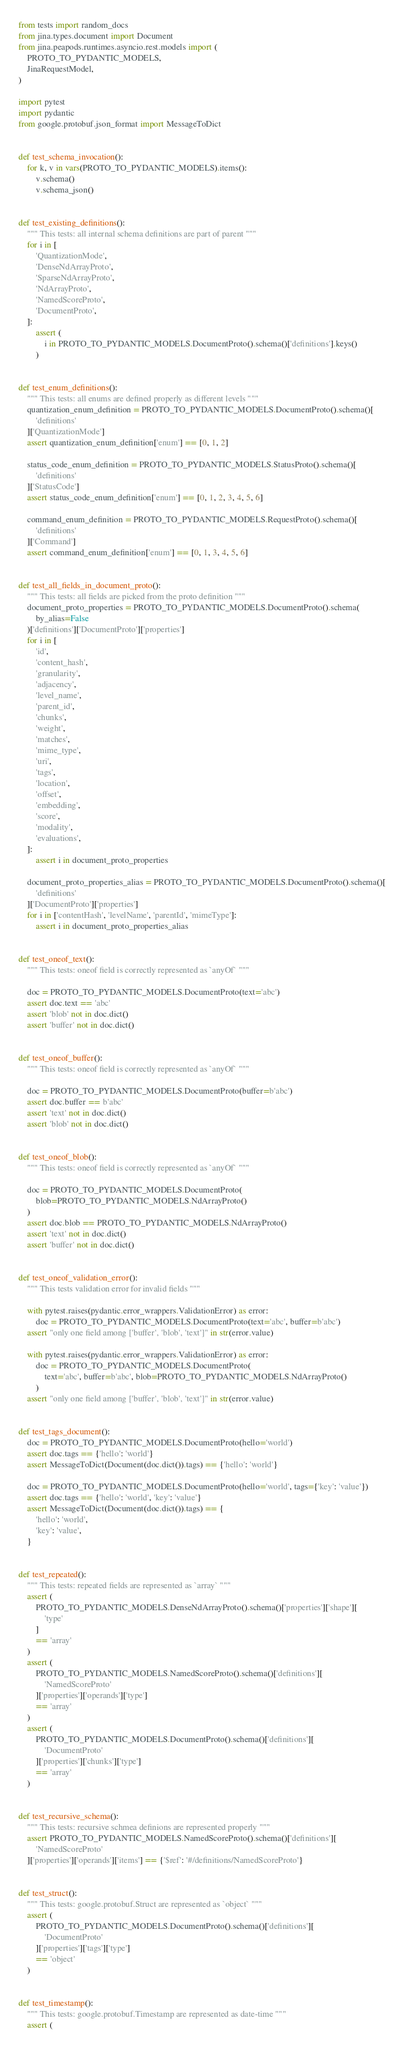Convert code to text. <code><loc_0><loc_0><loc_500><loc_500><_Python_>from tests import random_docs
from jina.types.document import Document
from jina.peapods.runtimes.asyncio.rest.models import (
    PROTO_TO_PYDANTIC_MODELS,
    JinaRequestModel,
)

import pytest
import pydantic
from google.protobuf.json_format import MessageToDict


def test_schema_invocation():
    for k, v in vars(PROTO_TO_PYDANTIC_MODELS).items():
        v.schema()
        v.schema_json()


def test_existing_definitions():
    """ This tests: all internal schema definitions are part of parent """
    for i in [
        'QuantizationMode',
        'DenseNdArrayProto',
        'SparseNdArrayProto',
        'NdArrayProto',
        'NamedScoreProto',
        'DocumentProto',
    ]:
        assert (
            i in PROTO_TO_PYDANTIC_MODELS.DocumentProto().schema()['definitions'].keys()
        )


def test_enum_definitions():
    """ This tests: all enums are defined properly as different levels """
    quantization_enum_definition = PROTO_TO_PYDANTIC_MODELS.DocumentProto().schema()[
        'definitions'
    ]['QuantizationMode']
    assert quantization_enum_definition['enum'] == [0, 1, 2]

    status_code_enum_definition = PROTO_TO_PYDANTIC_MODELS.StatusProto().schema()[
        'definitions'
    ]['StatusCode']
    assert status_code_enum_definition['enum'] == [0, 1, 2, 3, 4, 5, 6]

    command_enum_definition = PROTO_TO_PYDANTIC_MODELS.RequestProto().schema()[
        'definitions'
    ]['Command']
    assert command_enum_definition['enum'] == [0, 1, 3, 4, 5, 6]


def test_all_fields_in_document_proto():
    """ This tests: all fields are picked from the proto definition """
    document_proto_properties = PROTO_TO_PYDANTIC_MODELS.DocumentProto().schema(
        by_alias=False
    )['definitions']['DocumentProto']['properties']
    for i in [
        'id',
        'content_hash',
        'granularity',
        'adjacency',
        'level_name',
        'parent_id',
        'chunks',
        'weight',
        'matches',
        'mime_type',
        'uri',
        'tags',
        'location',
        'offset',
        'embedding',
        'score',
        'modality',
        'evaluations',
    ]:
        assert i in document_proto_properties

    document_proto_properties_alias = PROTO_TO_PYDANTIC_MODELS.DocumentProto().schema()[
        'definitions'
    ]['DocumentProto']['properties']
    for i in ['contentHash', 'levelName', 'parentId', 'mimeType']:
        assert i in document_proto_properties_alias


def test_oneof_text():
    """ This tests: oneof field is correctly represented as `anyOf` """

    doc = PROTO_TO_PYDANTIC_MODELS.DocumentProto(text='abc')
    assert doc.text == 'abc'
    assert 'blob' not in doc.dict()
    assert 'buffer' not in doc.dict()


def test_oneof_buffer():
    """ This tests: oneof field is correctly represented as `anyOf` """

    doc = PROTO_TO_PYDANTIC_MODELS.DocumentProto(buffer=b'abc')
    assert doc.buffer == b'abc'
    assert 'text' not in doc.dict()
    assert 'blob' not in doc.dict()


def test_oneof_blob():
    """ This tests: oneof field is correctly represented as `anyOf` """

    doc = PROTO_TO_PYDANTIC_MODELS.DocumentProto(
        blob=PROTO_TO_PYDANTIC_MODELS.NdArrayProto()
    )
    assert doc.blob == PROTO_TO_PYDANTIC_MODELS.NdArrayProto()
    assert 'text' not in doc.dict()
    assert 'buffer' not in doc.dict()


def test_oneof_validation_error():
    """ This tests validation error for invalid fields """

    with pytest.raises(pydantic.error_wrappers.ValidationError) as error:
        doc = PROTO_TO_PYDANTIC_MODELS.DocumentProto(text='abc', buffer=b'abc')
    assert "only one field among ['buffer', 'blob', 'text']" in str(error.value)

    with pytest.raises(pydantic.error_wrappers.ValidationError) as error:
        doc = PROTO_TO_PYDANTIC_MODELS.DocumentProto(
            text='abc', buffer=b'abc', blob=PROTO_TO_PYDANTIC_MODELS.NdArrayProto()
        )
    assert "only one field among ['buffer', 'blob', 'text']" in str(error.value)


def test_tags_document():
    doc = PROTO_TO_PYDANTIC_MODELS.DocumentProto(hello='world')
    assert doc.tags == {'hello': 'world'}
    assert MessageToDict(Document(doc.dict()).tags) == {'hello': 'world'}

    doc = PROTO_TO_PYDANTIC_MODELS.DocumentProto(hello='world', tags={'key': 'value'})
    assert doc.tags == {'hello': 'world', 'key': 'value'}
    assert MessageToDict(Document(doc.dict()).tags) == {
        'hello': 'world',
        'key': 'value',
    }


def test_repeated():
    """ This tests: repeated fields are represented as `array` """
    assert (
        PROTO_TO_PYDANTIC_MODELS.DenseNdArrayProto().schema()['properties']['shape'][
            'type'
        ]
        == 'array'
    )
    assert (
        PROTO_TO_PYDANTIC_MODELS.NamedScoreProto().schema()['definitions'][
            'NamedScoreProto'
        ]['properties']['operands']['type']
        == 'array'
    )
    assert (
        PROTO_TO_PYDANTIC_MODELS.DocumentProto().schema()['definitions'][
            'DocumentProto'
        ]['properties']['chunks']['type']
        == 'array'
    )


def test_recursive_schema():
    """ This tests: recursive schmea definions are represented properly """
    assert PROTO_TO_PYDANTIC_MODELS.NamedScoreProto().schema()['definitions'][
        'NamedScoreProto'
    ]['properties']['operands']['items'] == {'$ref': '#/definitions/NamedScoreProto'}


def test_struct():
    """ This tests: google.protobuf.Struct are represented as `object` """
    assert (
        PROTO_TO_PYDANTIC_MODELS.DocumentProto().schema()['definitions'][
            'DocumentProto'
        ]['properties']['tags']['type']
        == 'object'
    )


def test_timestamp():
    """ This tests: google.protobuf.Timestamp are represented as date-time """
    assert (</code> 